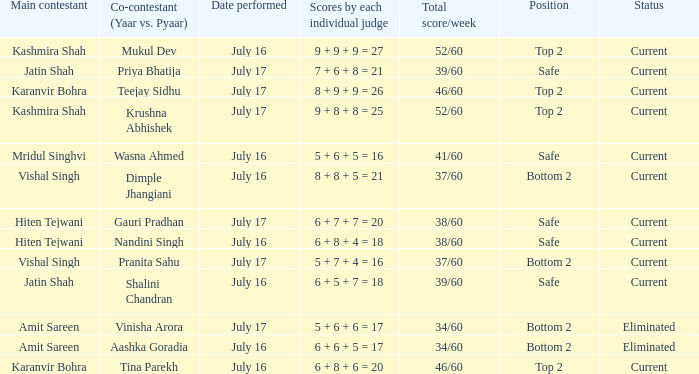What position did Pranita Sahu's team get? Bottom 2. 